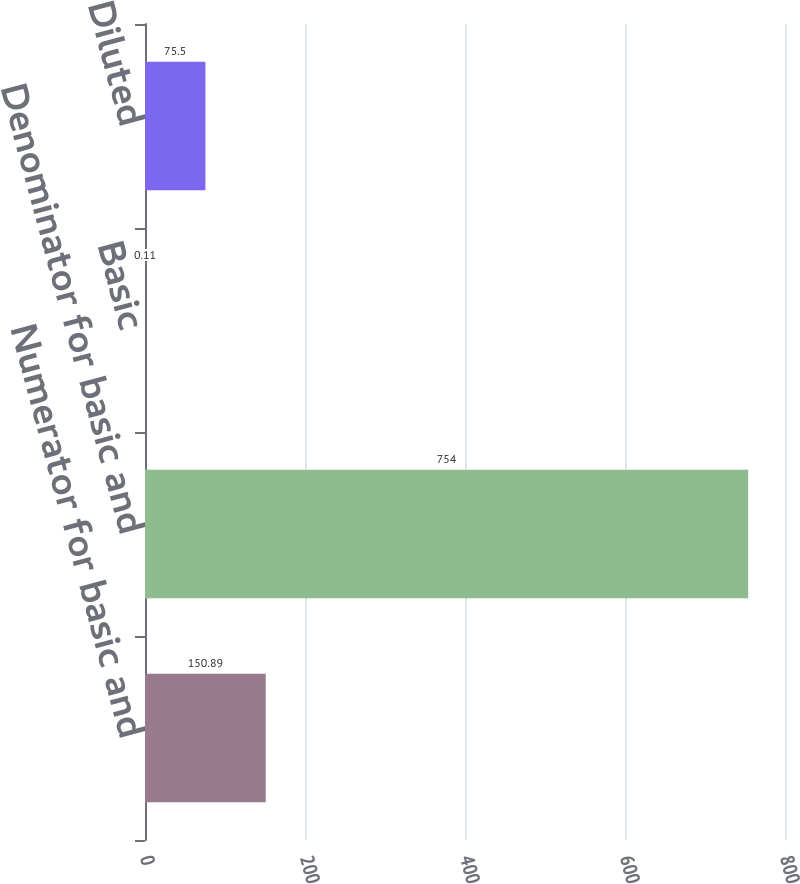Convert chart. <chart><loc_0><loc_0><loc_500><loc_500><bar_chart><fcel>Numerator for basic and<fcel>Denominator for basic and<fcel>Basic<fcel>Diluted<nl><fcel>150.89<fcel>754<fcel>0.11<fcel>75.5<nl></chart> 